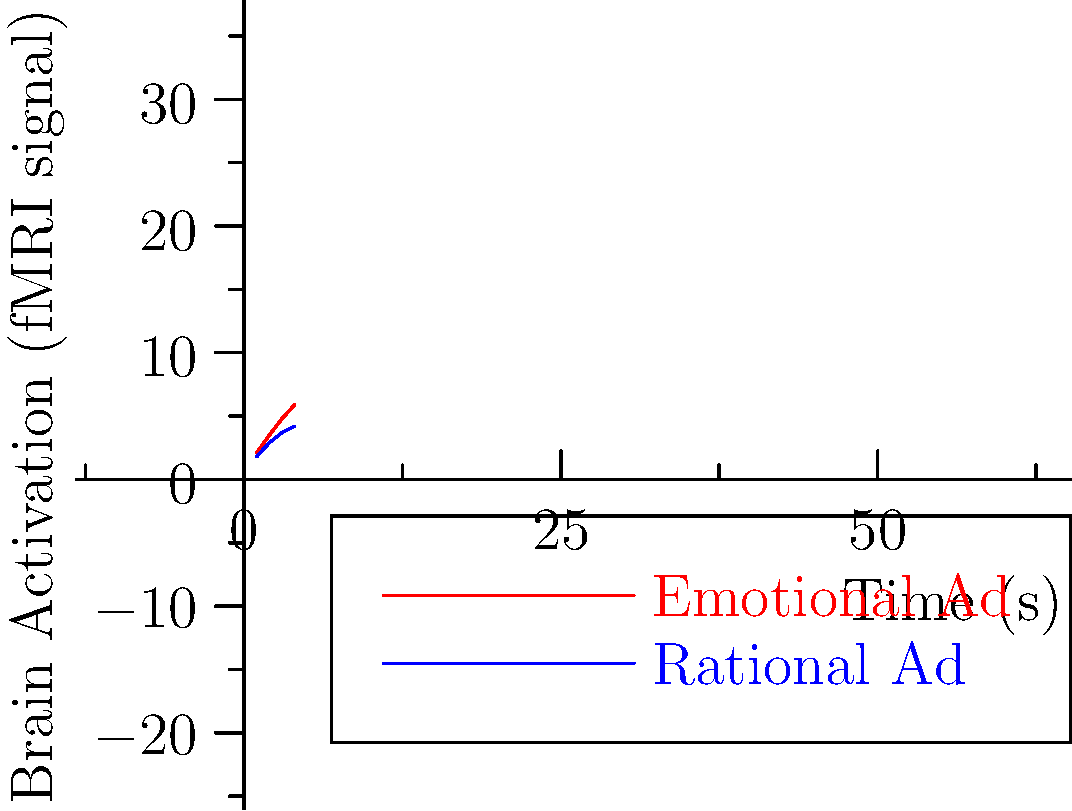Based on the fMRI brain activation patterns shown in the graph, which type of advertising stimulus appears to elicit a stronger neural response over time, and what implications might this have for neuromarketing strategies? To answer this question, we need to analyze the graph and interpret its implications for neuromarketing:

1. Graph interpretation:
   - The x-axis represents time in seconds.
   - The y-axis represents brain activation measured by fMRI signal intensity.
   - Two lines are plotted: red for "Emotional Ad" and blue for "Rational Ad".

2. Comparing the lines:
   - The red line (Emotional Ad) shows consistently higher values than the blue line (Rational Ad).
   - Both lines show an increasing trend over time, but the red line increases more steeply.

3. Neural response strength:
   - The Emotional Ad elicits a stronger neural response throughout the measured time period.
   - By the end of the measurement (4 seconds), the Emotional Ad's activation is approximately 40% higher than the Rational Ad's.

4. Implications for neuromarketing:
   - Emotional content appears to be more effective in engaging brain activity.
   - This suggests that emotional appeals in advertising may be more impactful on consumers' neural responses.
   - Neuromarketing strategies might benefit from incorporating more emotional elements in advertising campaigns.

5. Considerations:
   - The specific brain regions activated are not shown, which could provide more detailed insights.
   - Individual differences and context might affect these responses in real-world scenarios.

6. Potential strategy:
   - Develop advertising that triggers emotional responses for stronger neural engagement.
   - Use emotional storytelling or imagery to enhance brand recall and consumer connection.
   - Test advertisements using fMRI to optimize emotional impact before large-scale deployment.
Answer: Emotional advertising elicits stronger neural responses, suggesting more effective consumer engagement for neuromarketing strategies. 